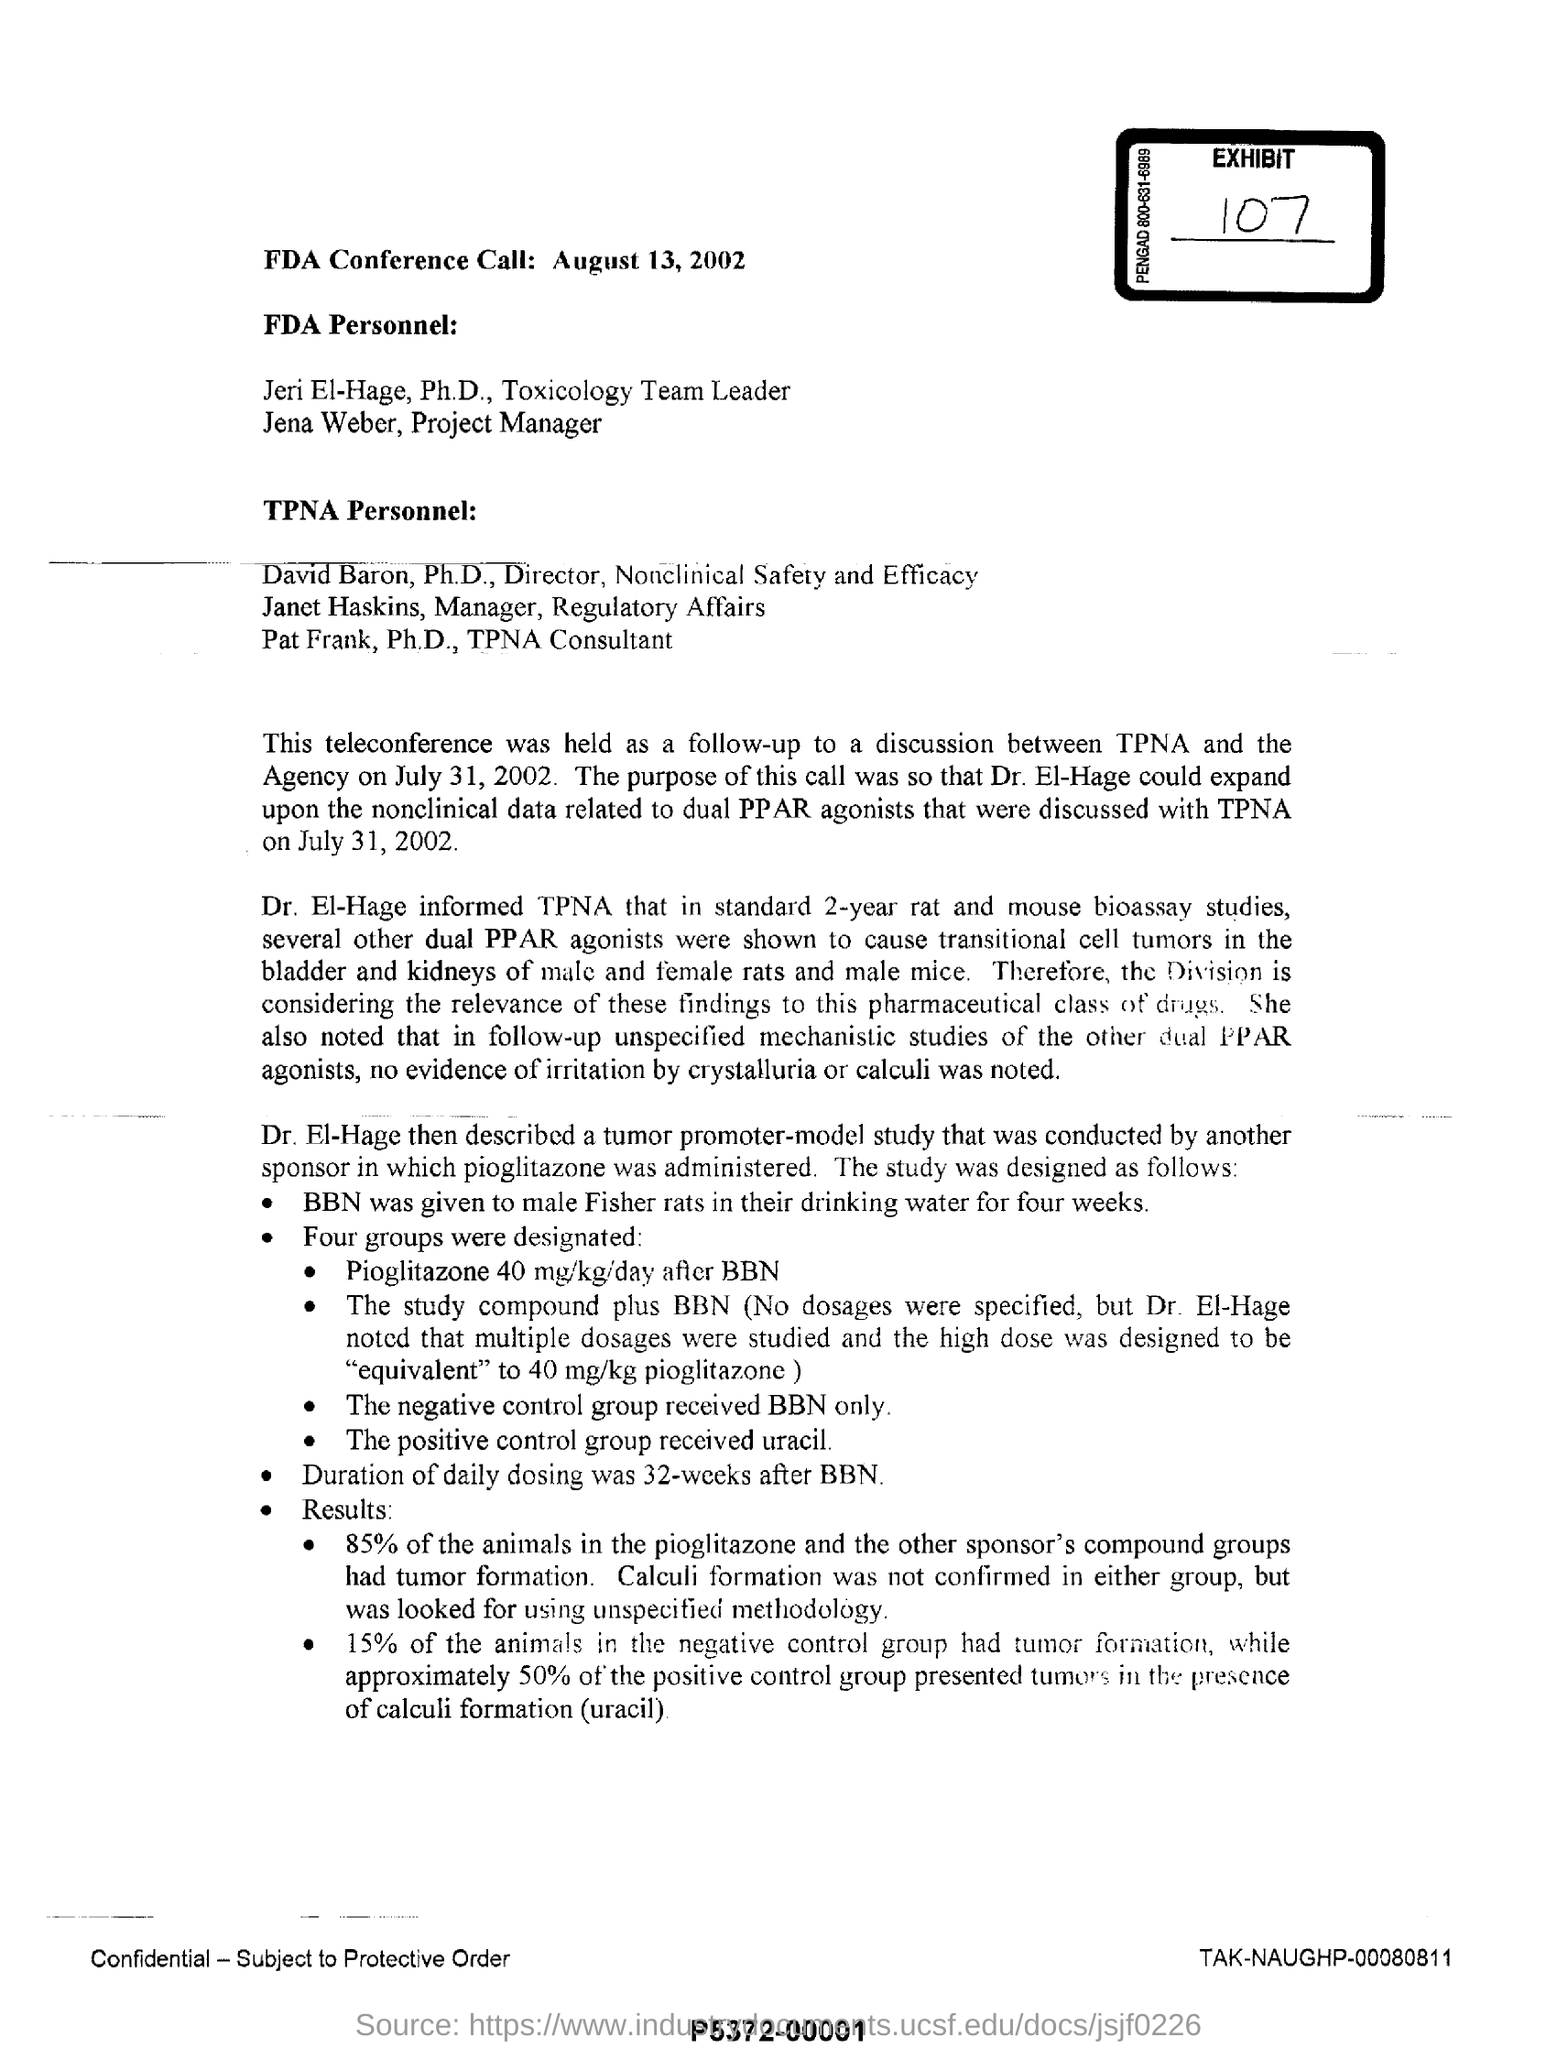What is the duration of daily dosing?
 32-weeks 